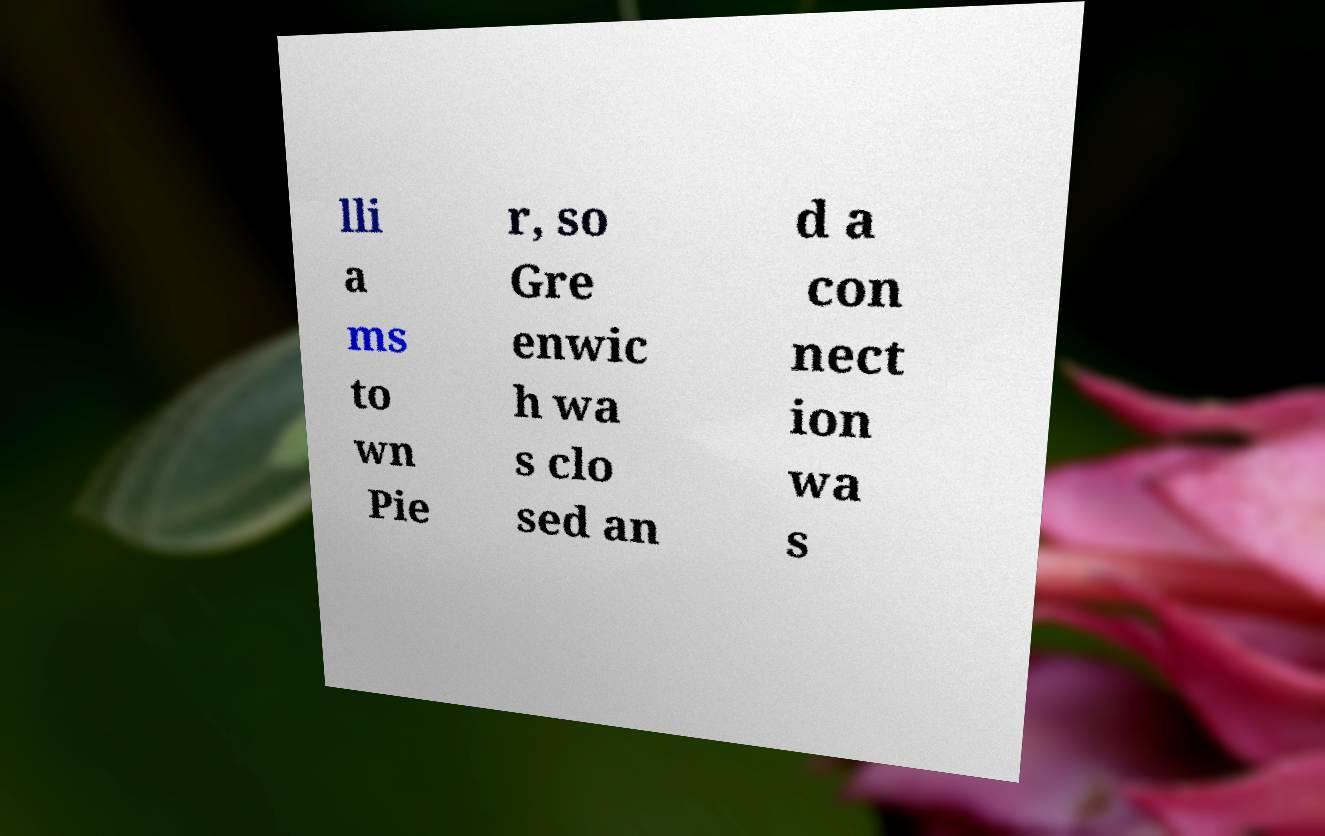What messages or text are displayed in this image? I need them in a readable, typed format. lli a ms to wn Pie r, so Gre enwic h wa s clo sed an d a con nect ion wa s 